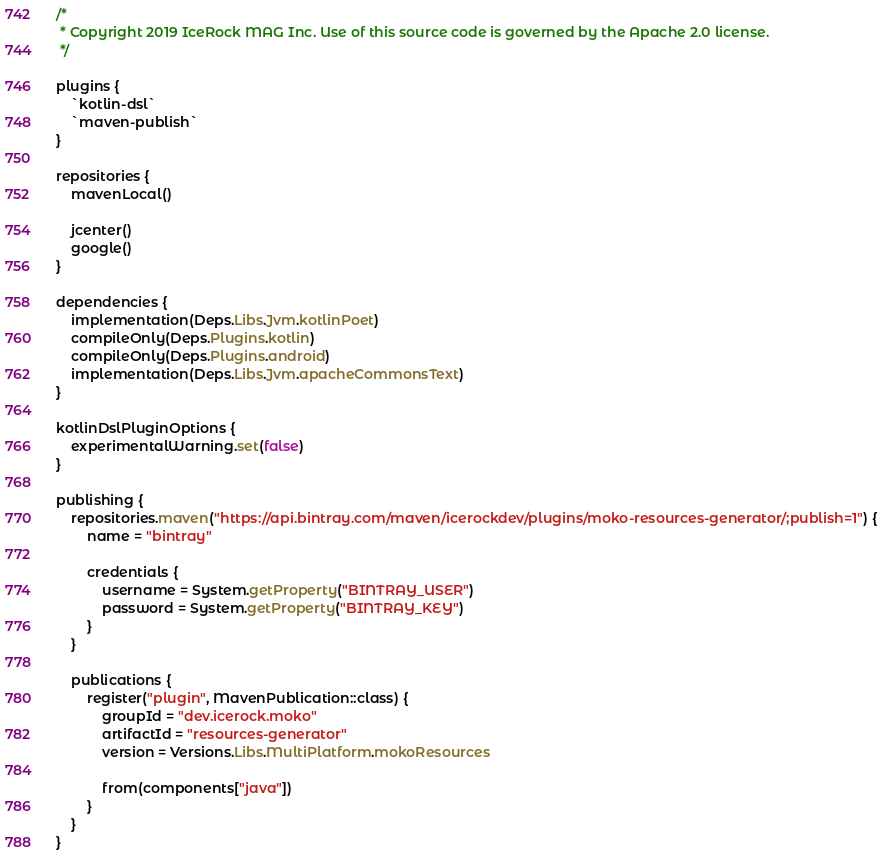<code> <loc_0><loc_0><loc_500><loc_500><_Kotlin_>/*
 * Copyright 2019 IceRock MAG Inc. Use of this source code is governed by the Apache 2.0 license.
 */

plugins {
    `kotlin-dsl`
    `maven-publish`
}

repositories {
    mavenLocal()

    jcenter()
    google()
}

dependencies {
    implementation(Deps.Libs.Jvm.kotlinPoet)
    compileOnly(Deps.Plugins.kotlin)
    compileOnly(Deps.Plugins.android)
    implementation(Deps.Libs.Jvm.apacheCommonsText)
}

kotlinDslPluginOptions {
    experimentalWarning.set(false)
}

publishing {
    repositories.maven("https://api.bintray.com/maven/icerockdev/plugins/moko-resources-generator/;publish=1") {
        name = "bintray"

        credentials {
            username = System.getProperty("BINTRAY_USER")
            password = System.getProperty("BINTRAY_KEY")
        }
    }

    publications {
        register("plugin", MavenPublication::class) {
            groupId = "dev.icerock.moko"
            artifactId = "resources-generator"
            version = Versions.Libs.MultiPlatform.mokoResources

            from(components["java"])
        }
    }
}
</code> 